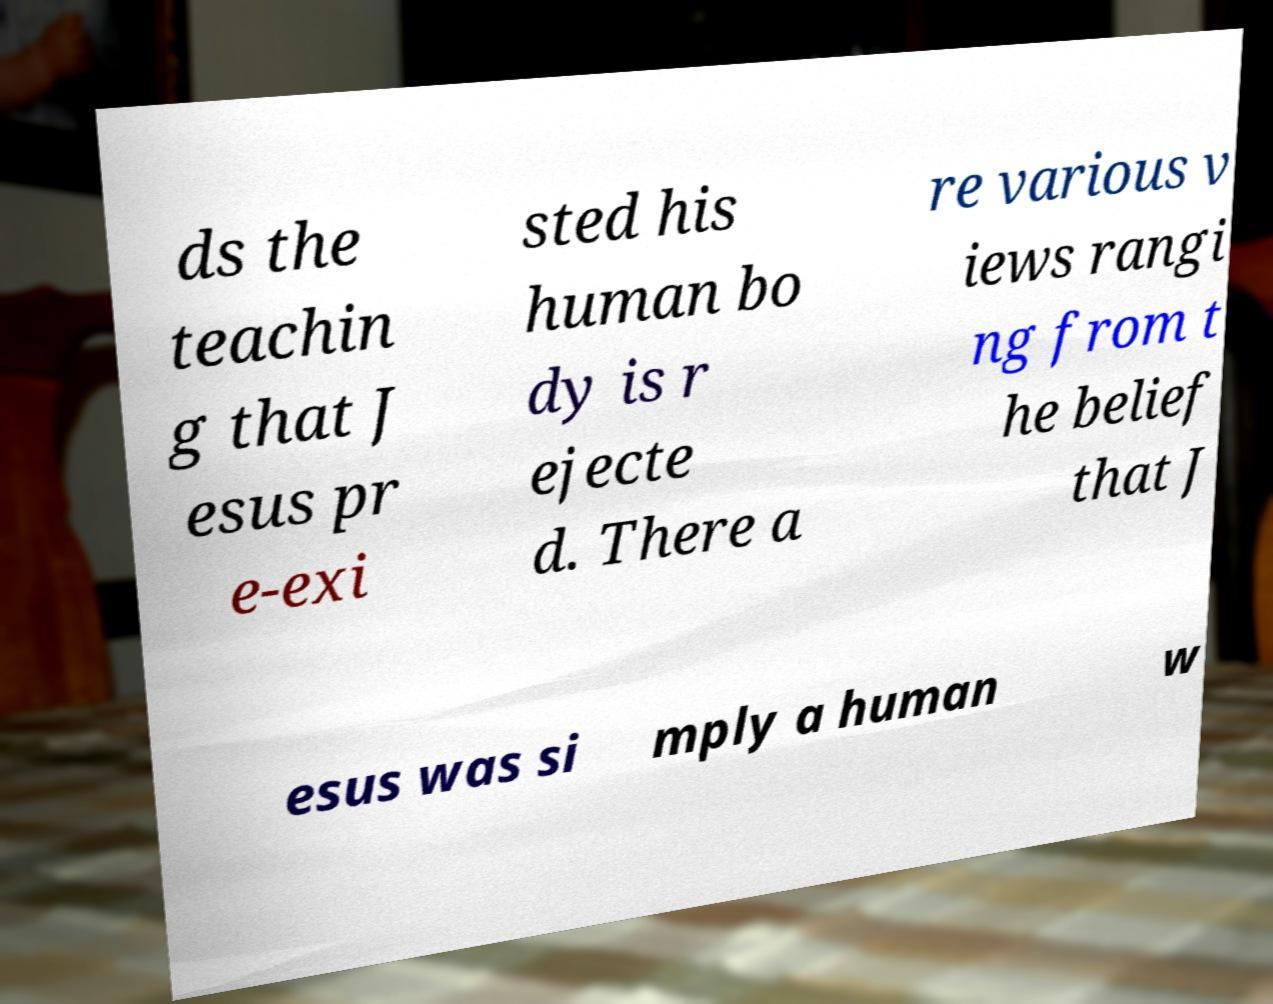Could you extract and type out the text from this image? ds the teachin g that J esus pr e-exi sted his human bo dy is r ejecte d. There a re various v iews rangi ng from t he belief that J esus was si mply a human w 